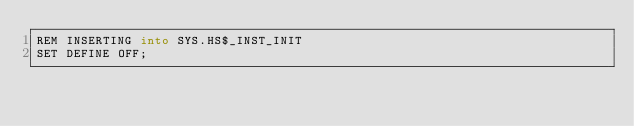Convert code to text. <code><loc_0><loc_0><loc_500><loc_500><_SQL_>REM INSERTING into SYS.HS$_INST_INIT
SET DEFINE OFF;
</code> 